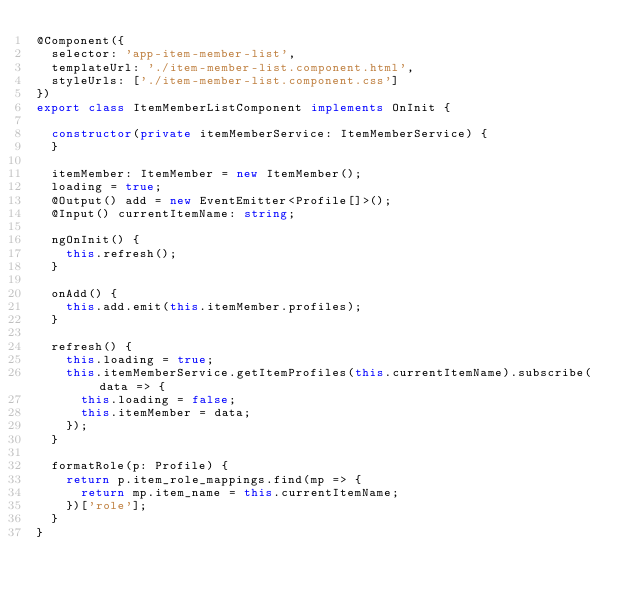<code> <loc_0><loc_0><loc_500><loc_500><_TypeScript_>@Component({
  selector: 'app-item-member-list',
  templateUrl: './item-member-list.component.html',
  styleUrls: ['./item-member-list.component.css']
})
export class ItemMemberListComponent implements OnInit {

  constructor(private itemMemberService: ItemMemberService) {
  }

  itemMember: ItemMember = new ItemMember();
  loading = true;
  @Output() add = new EventEmitter<Profile[]>();
  @Input() currentItemName: string;

  ngOnInit() {
    this.refresh();
  }

  onAdd() {
    this.add.emit(this.itemMember.profiles);
  }

  refresh() {
    this.loading = true;
    this.itemMemberService.getItemProfiles(this.currentItemName).subscribe(data => {
      this.loading = false;
      this.itemMember = data;
    });
  }

  formatRole(p: Profile) {
    return p.item_role_mappings.find(mp => {
      return mp.item_name = this.currentItemName;
    })['role'];
  }
}
</code> 